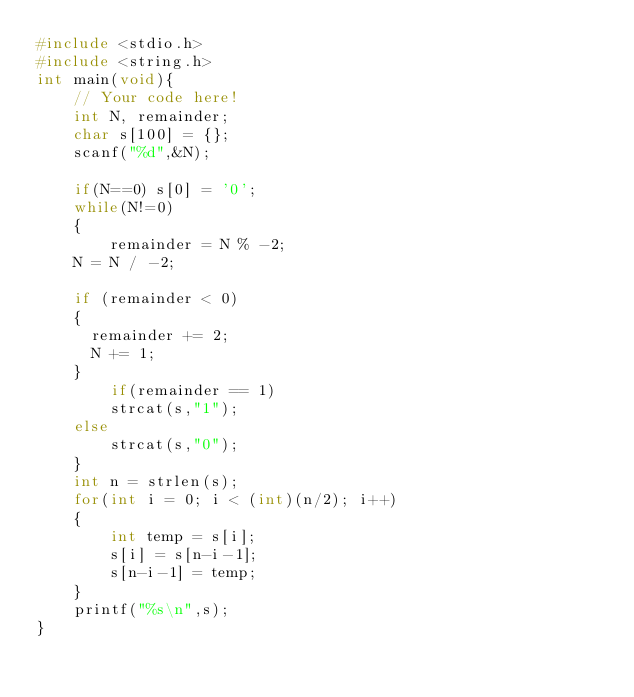<code> <loc_0><loc_0><loc_500><loc_500><_C_>#include <stdio.h>
#include <string.h>
int main(void){
    // Your code here!
    int N, remainder;
    char s[100] = {};
    scanf("%d",&N);
    
    if(N==0) s[0] = '0';
    while(N!=0)
    {
        remainder = N % -2;
		N = N / -2;

		if (remainder < 0)
		{
			remainder += 2;
			N += 1;
		}
        if(remainder == 1)
		    strcat(s,"1");
		else
		    strcat(s,"0");
    }
    int n = strlen(s);
    for(int i = 0; i < (int)(n/2); i++)
    {
        int temp = s[i];
        s[i] = s[n-i-1];
        s[n-i-1] = temp;
    }
    printf("%s\n",s);
}
</code> 